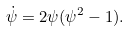Convert formula to latex. <formula><loc_0><loc_0><loc_500><loc_500>\dot { \psi } = 2 \psi ( \psi ^ { 2 } - 1 ) .</formula> 